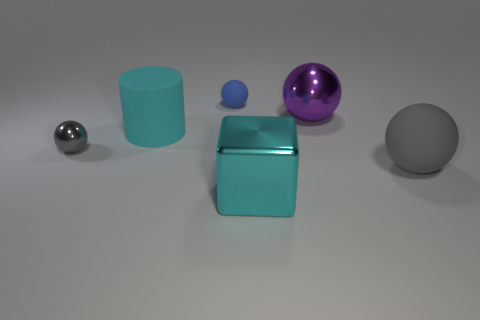How many tiny gray objects are the same shape as the purple object?
Ensure brevity in your answer.  1. Do the small gray metal thing and the small blue rubber object have the same shape?
Make the answer very short. Yes. The gray rubber ball has what size?
Provide a short and direct response. Large. How many cyan matte things are the same size as the purple shiny object?
Ensure brevity in your answer.  1. Do the gray sphere in front of the small shiny sphere and the object that is on the left side of the cylinder have the same size?
Offer a very short reply. No. There is a tiny object that is behind the big cyan cylinder; what shape is it?
Offer a very short reply. Sphere. What material is the gray thing in front of the shiny sphere in front of the purple ball?
Give a very brief answer. Rubber. Are there any metal spheres of the same color as the rubber cylinder?
Offer a very short reply. No. There is a purple thing; is its size the same as the matte ball that is in front of the small gray metallic ball?
Provide a succinct answer. Yes. What number of balls are on the right side of the blue sphere that is on the left side of the big matte thing that is on the right side of the purple metallic ball?
Provide a short and direct response. 2. 